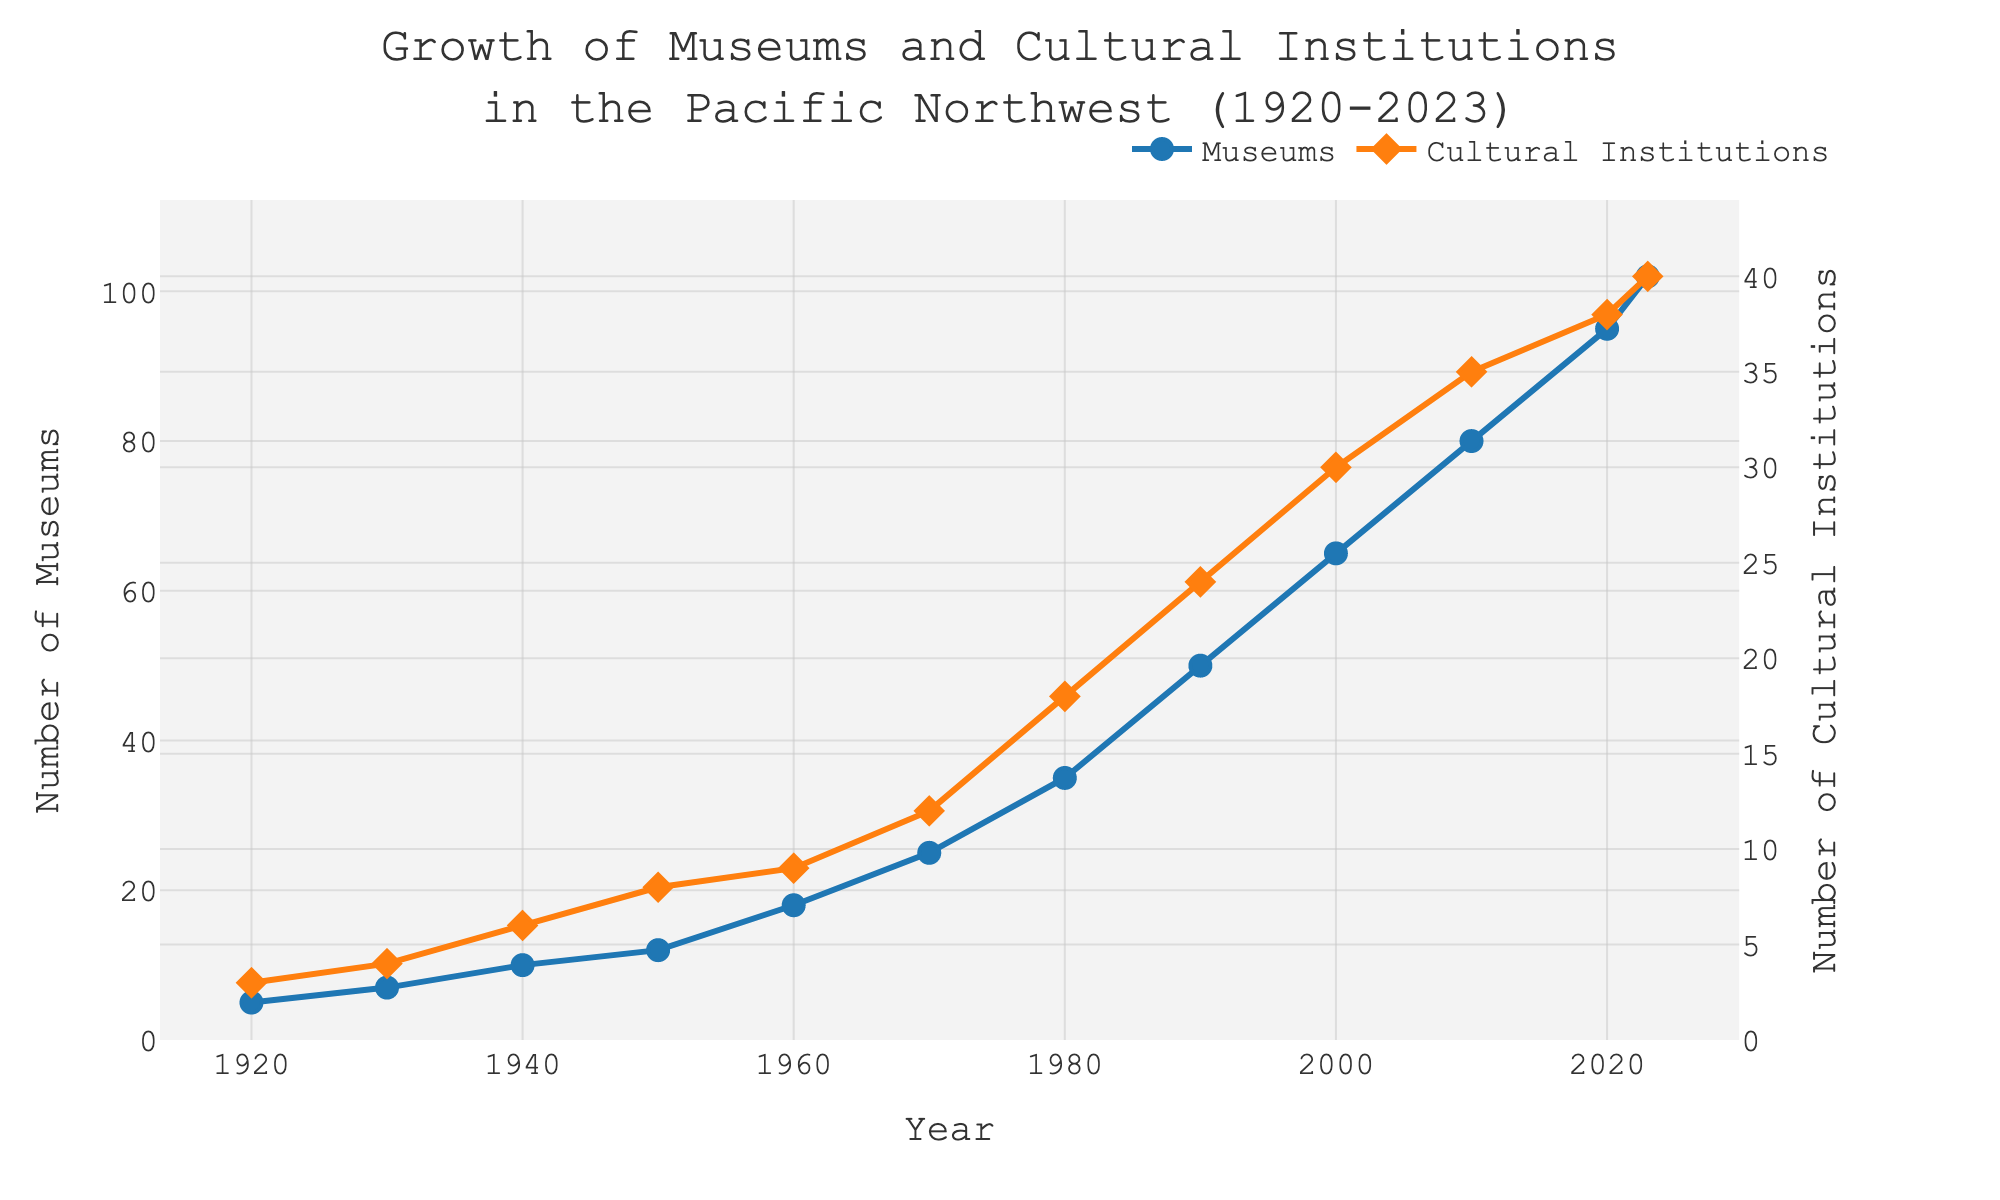What is the title of the plot? The title is displayed at the top of the plot. It reads "Growth of Museums and Cultural Institutions in the Pacific Northwest (1920-2023)."
Answer: Growth of Museums and Cultural Institutions in the Pacific Northwest (1920-2023) How many data points are there for museums? The figure has markers at each data point along the line graph for museums. Each marker represents one data point. Counting these markers gives us the total number of data points.
Answer: 12 What is the range of years shown on the x-axis? The x-axis starts at 1920 and ends at 2023. This can be inferred by looking at the labels on the x-axis.
Answer: 1920 to 2023 What was the number of cultural institutions in 1950? The plot has distinct points marked for each year. Locate the year 1950 on the x-axis and follow it up to the cultural institution data points (orange points).
Answer: 8 During which decade did the number of museums show the most significant increase? Compare the differences in the number of museums between subsequent decades by observing the slope of the line. The steepest slope indicates the most significant increase.
Answer: 1980-1990 How many new cultural institutions were established between 2010 and 2023? Locate the points for cultural institutions in 2010 and 2023. Subtract the value at 2010 from the value at 2023 (40 - 35).
Answer: 5 What trend can be observed for the number of museums from 1940 to 1970? Observe the line representing museums from 1940 to 1970. The line shows how the number of museums changes over time within this period. The line steadily increases.
Answer: Steady increase How does the number of museums in 2020 compare to the number of cultural institutions in 2020? Locate the number of museums and cultural institutions for the year 2020 on their respective lines. Compare these values.
Answer: Museums: 95, Cultural Institutions: 38 What is the average number of museums per decade between 1980 and 2020? List the number of museums for each decade from 1980 to 2020 (35, 50, 65, 80, 95). Calculate the average by summing these numbers and dividing by the number of decades. (35+50+65+80+95)/5 = 325/5 = 65
Answer: 65 Are there more cultural institutions or museums in 1920? By how much? Find the values for cultural institutions and museums in 1920 on the y-axis. Compare these values and calculate the difference (5 - 3).
Answer: Museums, by 2 